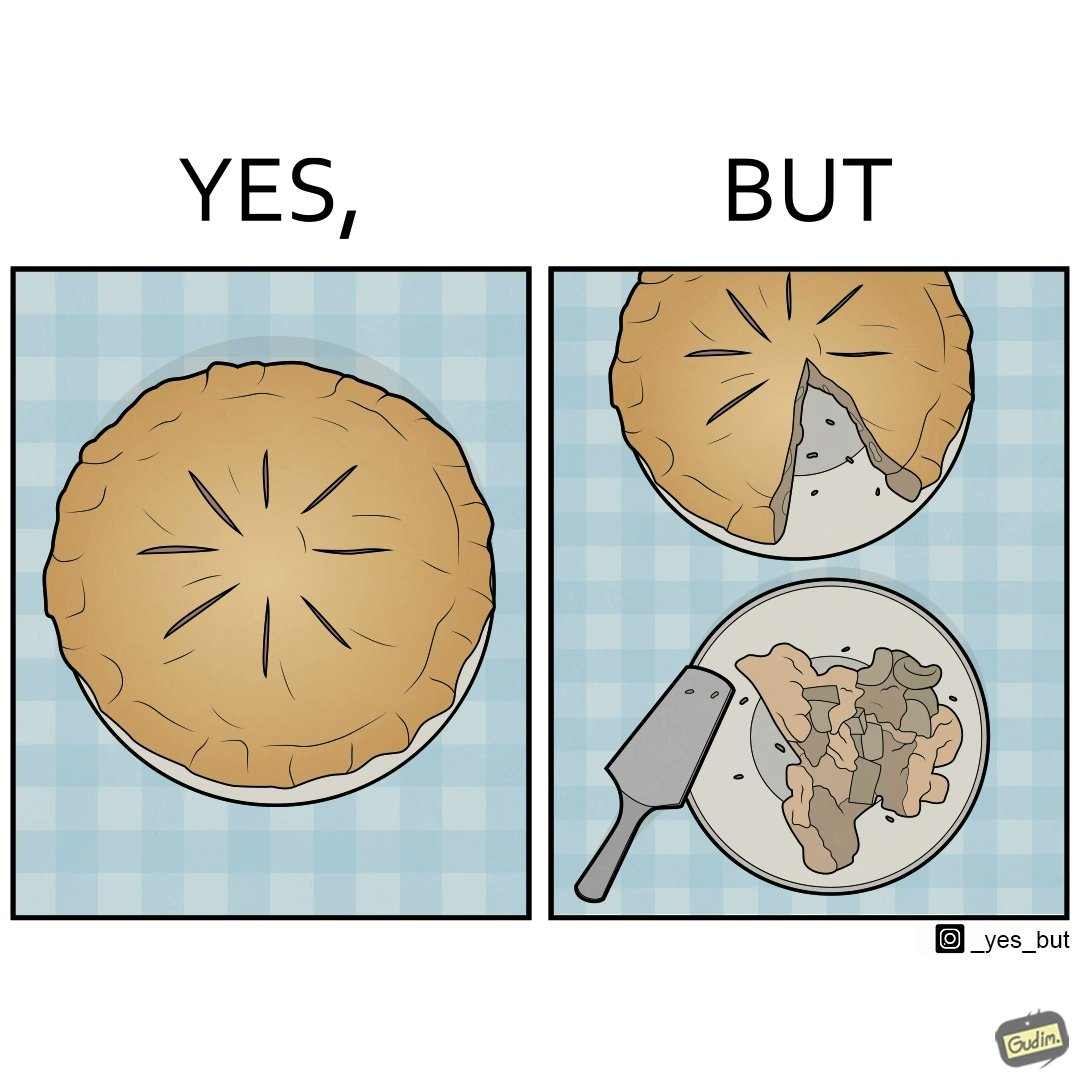What is shown in the left half versus the right half of this image? In the left part of the image: The image shows a complete pie on a plate. In the right part of the image: The image shows a slice of the pie on a smaller plate. The rest of the pie is on the original plate. 